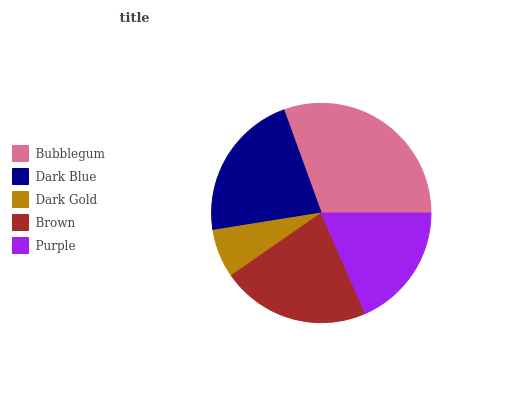Is Dark Gold the minimum?
Answer yes or no. Yes. Is Bubblegum the maximum?
Answer yes or no. Yes. Is Dark Blue the minimum?
Answer yes or no. No. Is Dark Blue the maximum?
Answer yes or no. No. Is Bubblegum greater than Dark Blue?
Answer yes or no. Yes. Is Dark Blue less than Bubblegum?
Answer yes or no. Yes. Is Dark Blue greater than Bubblegum?
Answer yes or no. No. Is Bubblegum less than Dark Blue?
Answer yes or no. No. Is Brown the high median?
Answer yes or no. Yes. Is Brown the low median?
Answer yes or no. Yes. Is Purple the high median?
Answer yes or no. No. Is Purple the low median?
Answer yes or no. No. 